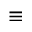Convert formula to latex. <formula><loc_0><loc_0><loc_500><loc_500>\equiv</formula> 